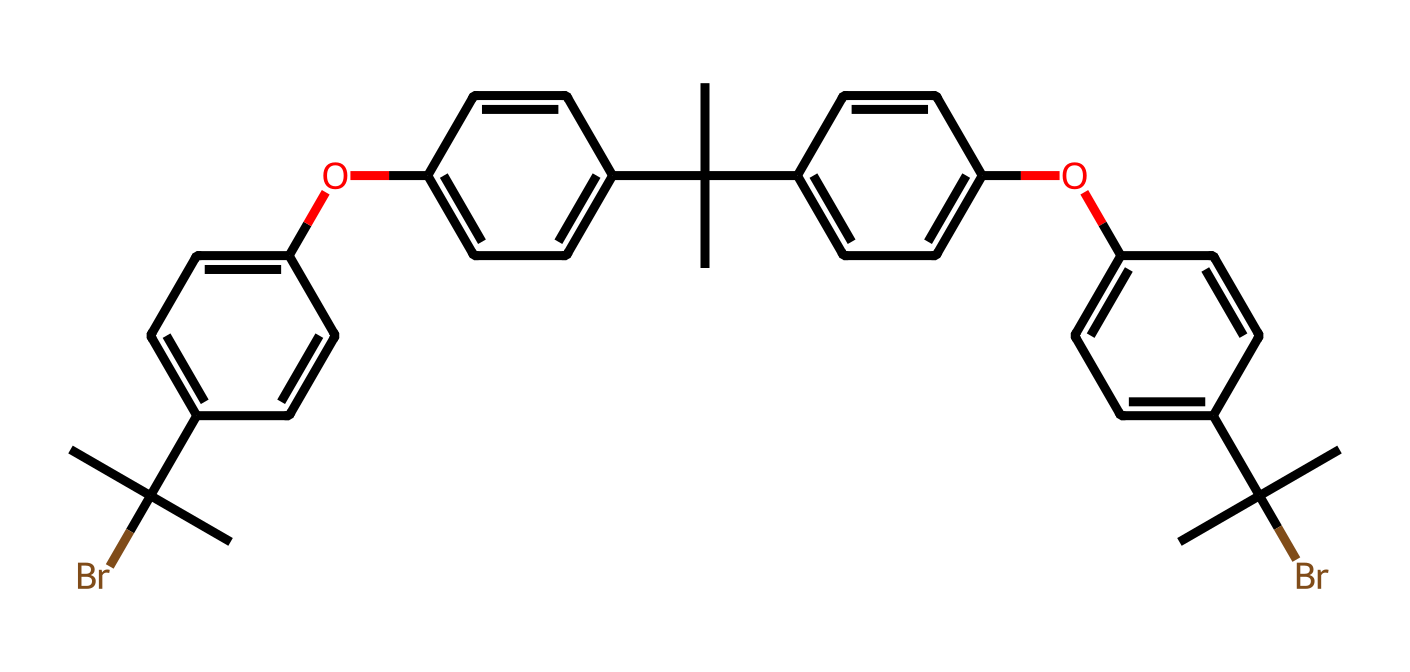What is the molecular formula of this polymer? To determine the molecular formula, count the number of each type of atom in the chemical structure represented by the SMILES notation. Each letter corresponds to an atom: 'C' for carbon, 'O' for oxygen, and 'Br' for bromine. I identify that there are 36 carbon atoms, 4 oxygen atoms, and 2 bromine atoms, resulting in the formula C36H36Br2O4.
Answer: C36H36Br2O4 How many aromatic rings are present in the structure? The presence of aromatic rings can be determined by looking for cyclic structures with alternating double bonds, indicated by 'c' in the SMILES. Scanning through the structure, I find 5 distinct aromatic systems formed by the cyclic and conjugated bonds. Therefore, there are 5 aromatic rings.
Answer: 5 What functional groups are evident in this polymer? Identifying the functional groups involves looking for specific notations in the SMILES that indicate different groups. Here, the 'Br' indicates the presence of bromo substituents, and 'O' indicates alkoxy groups attached to aromatic rings. Notably, there are both bromine and ether groups (due to 'Oc' components) in the chemical structure.
Answer: bromo and ether What is the role of bromine in this polymer's structure? The presence of bromine in the structure typically indicates its role as a flame retardant. Bromine contributes to the polymer's ability to inhibit flame propagation due to its chemical properties at high temperatures, including radical formation that interrupts combustion processes.
Answer: flame retardant Why might this polymer be suitable for computer hardware casings? Polymers used in computer hardware casings need to be thermally stable, flame-resistant, and durable. The structural features including dense cyclization and halogen substitutions improve heat resistance and diminish flammability, making this polymer especially suitable for such applications.
Answer: thermally stable and flame-resistant 